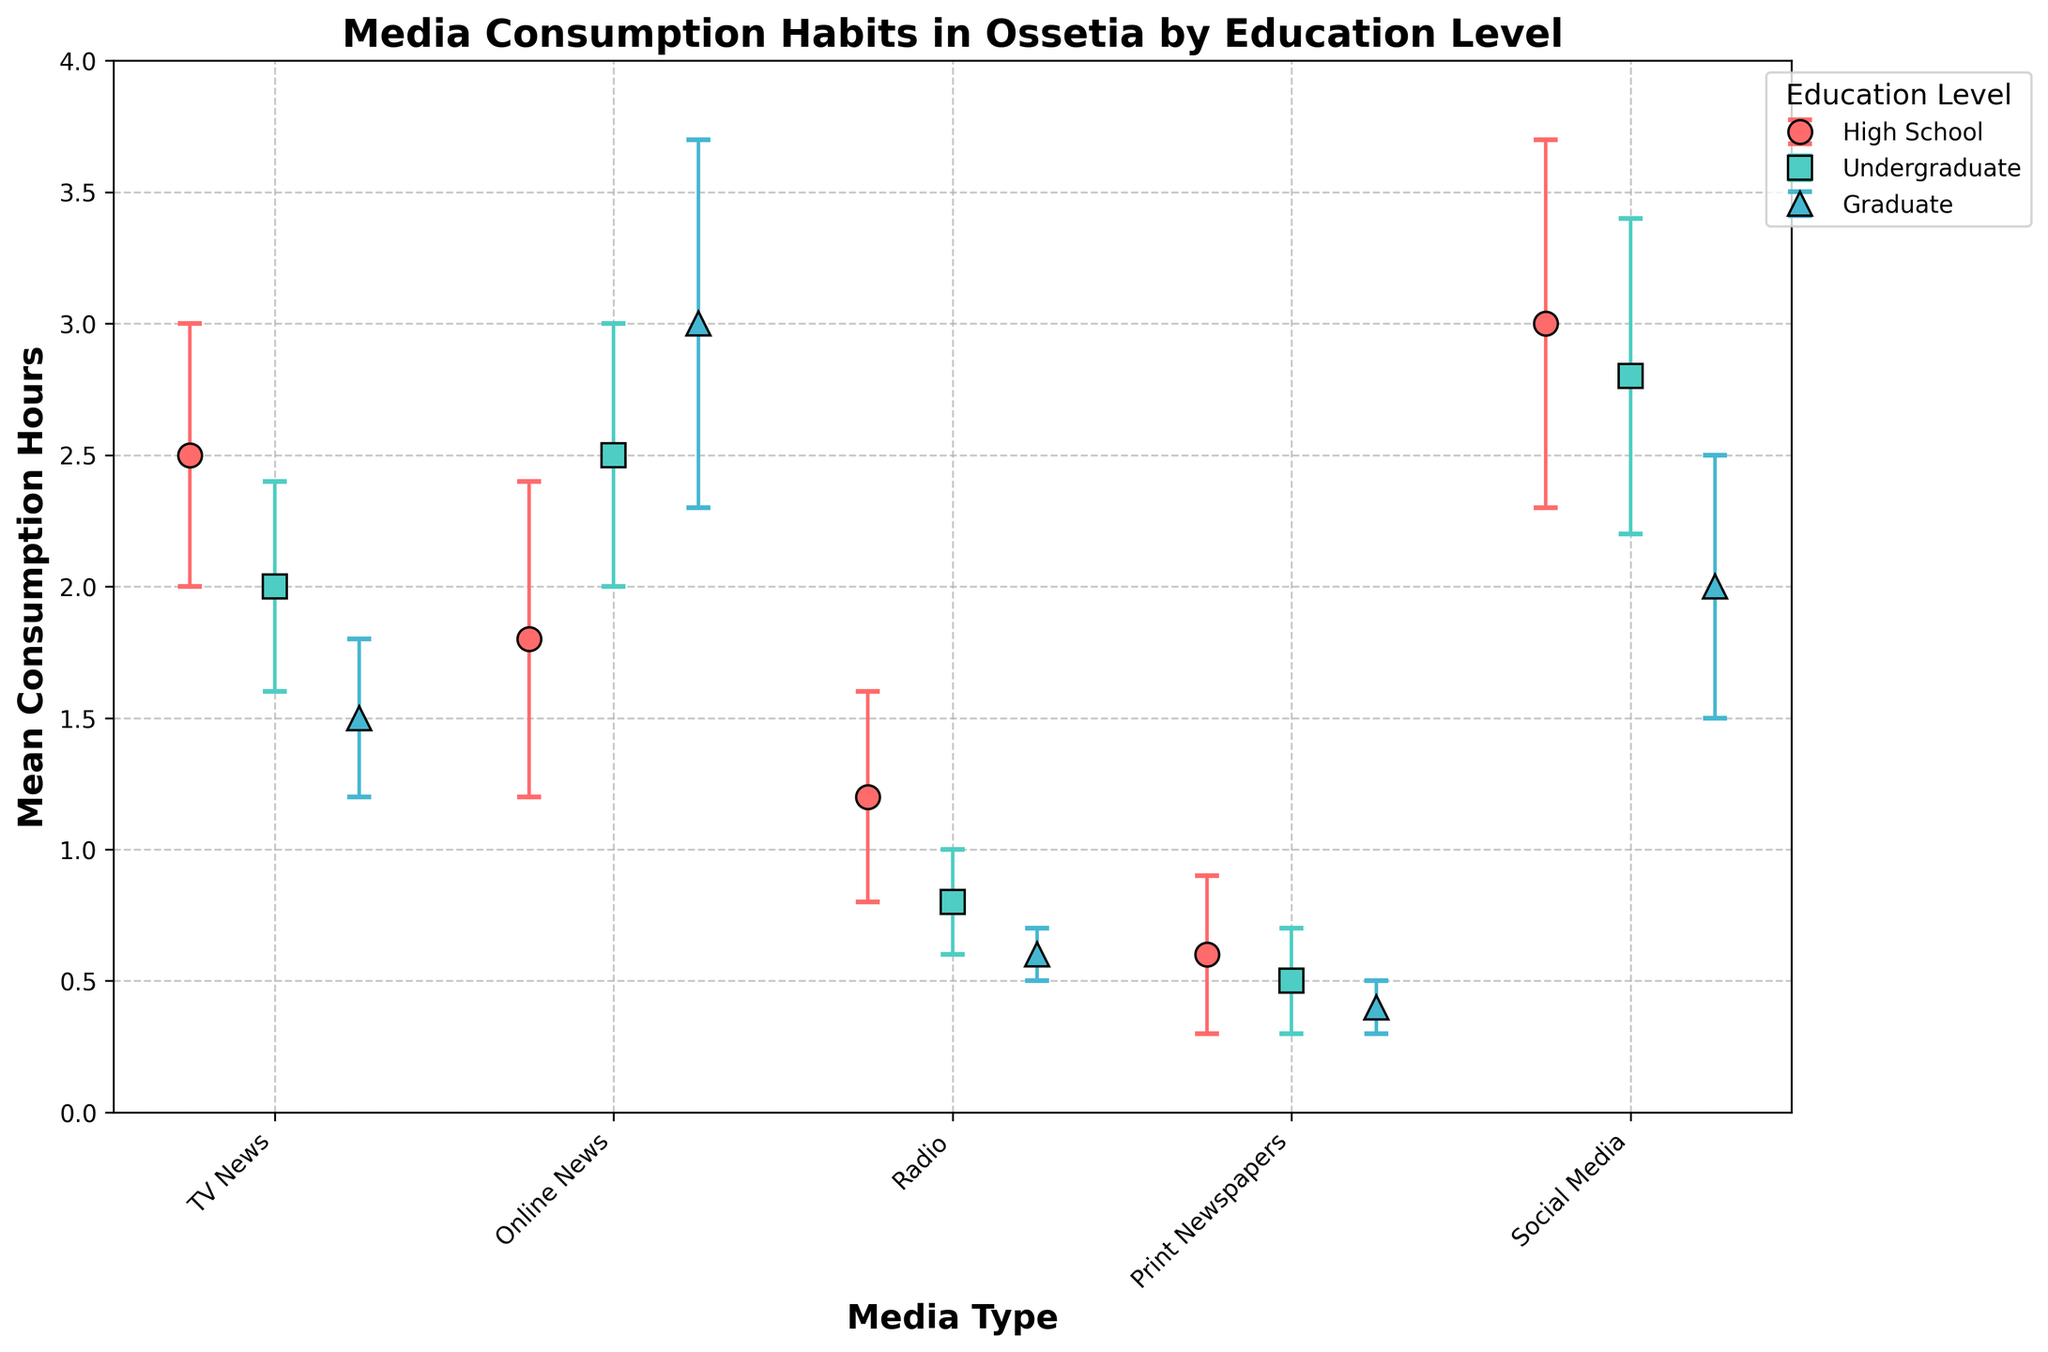What is the title of the figure? To find the title, look at the top center of the graph where the title is typically placed. In this case, it is located there and states the main idea of the figure.
Answer: Media Consumption Habits in Ossetia by Education Level Which media type has the highest mean consumption hours for individuals with a High School education level? Find the data points corresponding to the High School group and compare the values for each media type.
Answer: Social Media Among the Graduate education level, which media type shows the lowest mean consumption? Observe the dots positioned lowest for the Graduate category.
Answer: Print Newspapers What is the difference in mean consumption hours for Online News between Undergraduate and Graduate education levels? Check the positions of the dots for Online News under both the Undergraduate and Graduate categories and calculate the difference.
Answer: 0.5 hours Which education level has the highest mean consumption of Online News and what is that value? Look at the media type "Online News" and identify which group's point is the highest.
Answer: Graduate, 3.0 hours For the media type "Radio," which education level has the minimum consumption, and what is the value? Compare the mean consumption values for Radio across all education levels and find the minimum.
Answer: Graduate, 0.6 hours Does any media type have the same mean consumption hours across all education levels? For each media type, check if any of them have dots at the same height across all education levels.
Answer: No Which education level has a higher mean consumption of Social Media, High School or Undergraduate? Compare the mean consumption values for Social Media between High School and Undergraduate.
Answer: High School What is the average mean consumption hours of Print Newspapers across all education levels? Sum up the mean consumption hours for Print Newspapers across the three education levels and then divide by three.
Answer: (0.6 + 0.5 + 0.4) / 3 = 0.5 hours How do the error bars for TV News consumption compare between High School and Undergraduate education levels? Observe the size of the error bars for TV News under both education levels and compare their lengths.
Answer: High School has larger error bars 